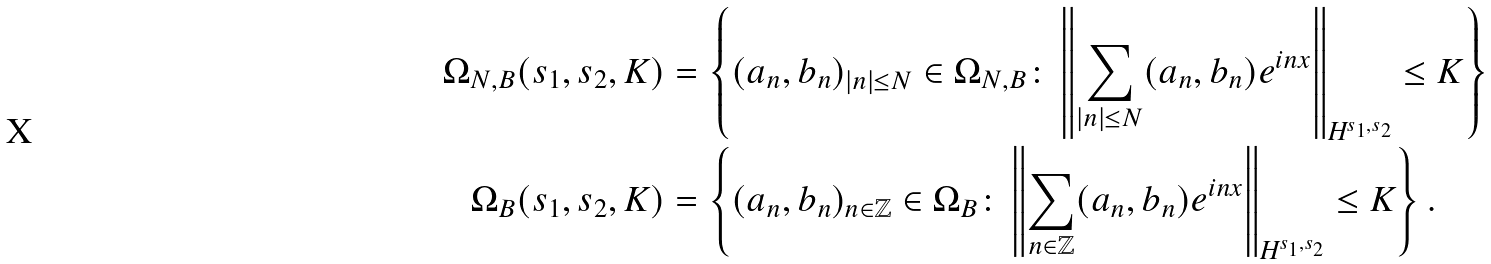<formula> <loc_0><loc_0><loc_500><loc_500>\Omega _ { N , B } ( s _ { 1 } , s _ { 2 } , K ) & = \left \{ ( a _ { n } , b _ { n } ) _ { | n | \leq N } \in \Omega _ { N , B } \colon \left \| \sum _ { | n | \leq N } ( a _ { n } , b _ { n } ) e ^ { i n x } \right \| _ { \text {H} ^ { s _ { 1 } , s _ { 2 } } } \leq K \right \} \\ \Omega _ { B } ( s _ { 1 } , s _ { 2 } , K ) & = \left \{ ( a _ { n } , b _ { n } ) _ { n \in \mathbb { Z } } \in \Omega _ { B } \colon \left \| \sum _ { n \in \mathbb { Z } } ( a _ { n } , b _ { n } ) e ^ { i n x } \right \| _ { \text {H} ^ { s _ { 1 } , s _ { 2 } } } \leq K \right \} .</formula> 